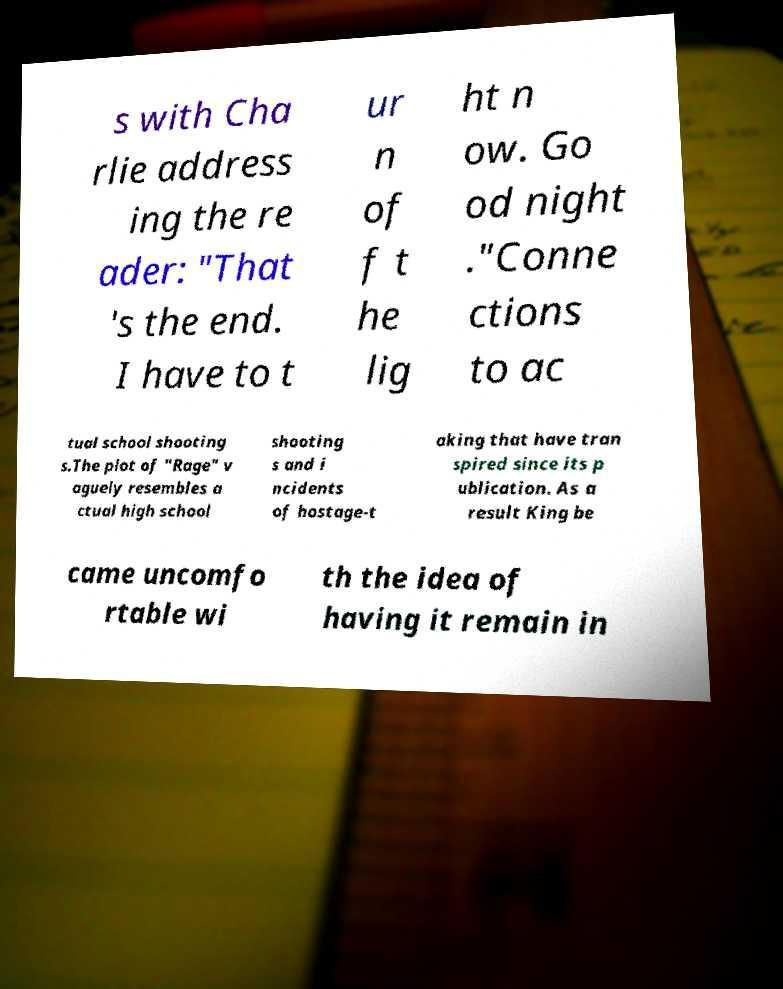I need the written content from this picture converted into text. Can you do that? s with Cha rlie address ing the re ader: "That 's the end. I have to t ur n of f t he lig ht n ow. Go od night ."Conne ctions to ac tual school shooting s.The plot of "Rage" v aguely resembles a ctual high school shooting s and i ncidents of hostage-t aking that have tran spired since its p ublication. As a result King be came uncomfo rtable wi th the idea of having it remain in 